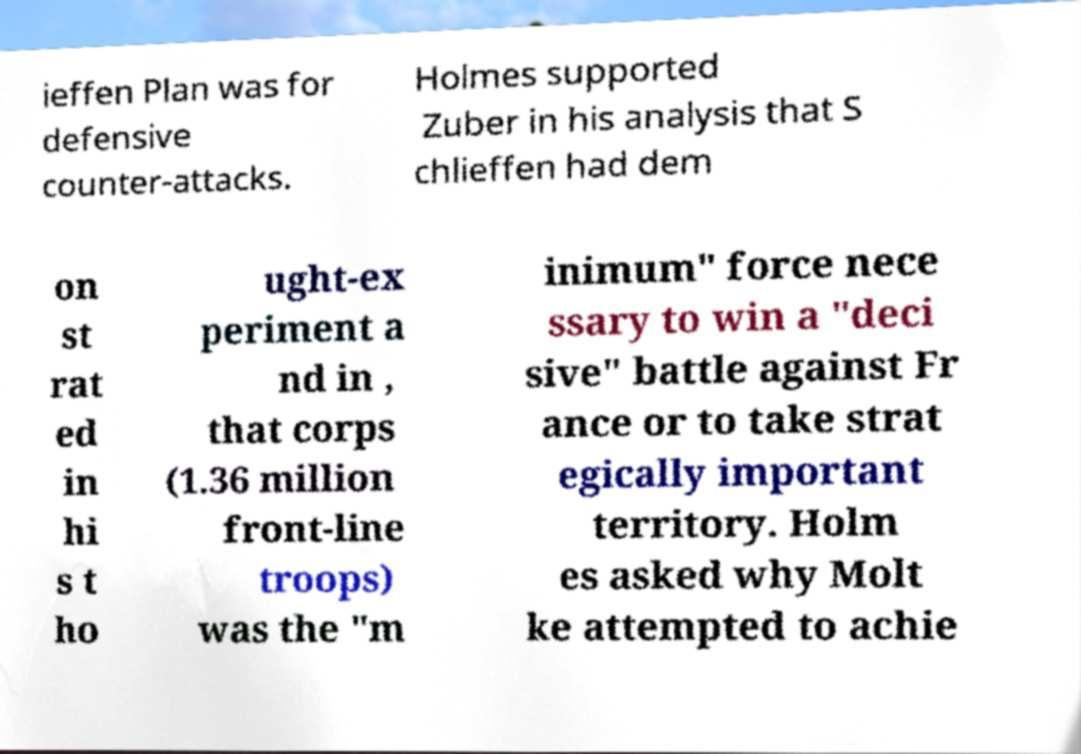Could you extract and type out the text from this image? ieffen Plan was for defensive counter-attacks. Holmes supported Zuber in his analysis that S chlieffen had dem on st rat ed in hi s t ho ught-ex periment a nd in , that corps (1.36 million front-line troops) was the "m inimum" force nece ssary to win a "deci sive" battle against Fr ance or to take strat egically important territory. Holm es asked why Molt ke attempted to achie 